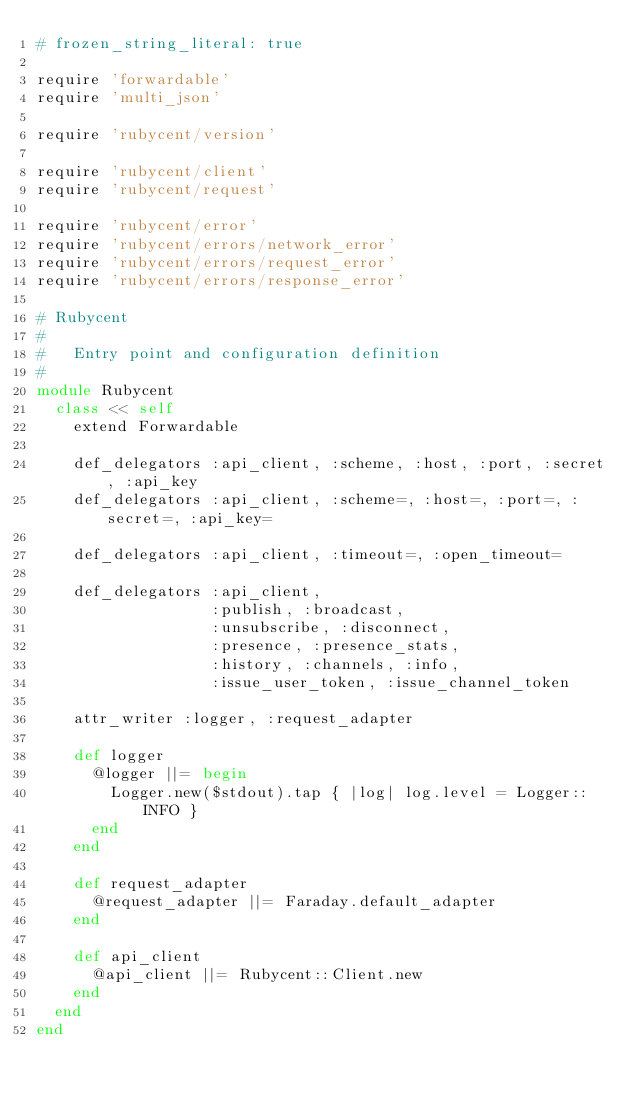<code> <loc_0><loc_0><loc_500><loc_500><_Ruby_># frozen_string_literal: true

require 'forwardable'
require 'multi_json'

require 'rubycent/version'

require 'rubycent/client'
require 'rubycent/request'

require 'rubycent/error'
require 'rubycent/errors/network_error'
require 'rubycent/errors/request_error'
require 'rubycent/errors/response_error'

# Rubycent
#
#   Entry point and configuration definition
#
module Rubycent
  class << self
    extend Forwardable

    def_delegators :api_client, :scheme, :host, :port, :secret, :api_key
    def_delegators :api_client, :scheme=, :host=, :port=, :secret=, :api_key=

    def_delegators :api_client, :timeout=, :open_timeout=

    def_delegators :api_client,
                   :publish, :broadcast,
                   :unsubscribe, :disconnect,
                   :presence, :presence_stats,
                   :history, :channels, :info,
                   :issue_user_token, :issue_channel_token

    attr_writer :logger, :request_adapter

    def logger
      @logger ||= begin
        Logger.new($stdout).tap { |log| log.level = Logger::INFO }
      end
    end

    def request_adapter
      @request_adapter ||= Faraday.default_adapter
    end

    def api_client
      @api_client ||= Rubycent::Client.new
    end
  end
end
</code> 